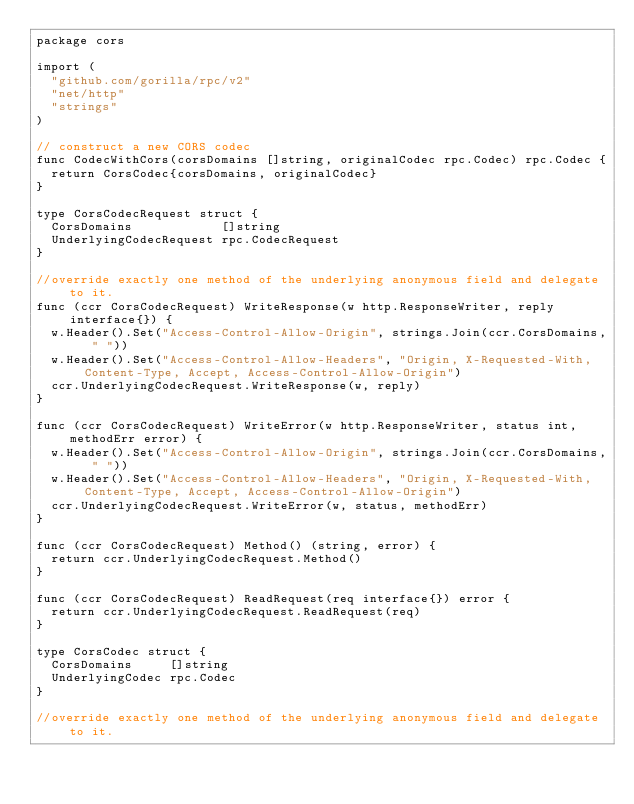Convert code to text. <code><loc_0><loc_0><loc_500><loc_500><_Go_>package cors

import (
	"github.com/gorilla/rpc/v2"
	"net/http"
	"strings"
)

// construct a new CORS codec
func CodecWithCors(corsDomains []string, originalCodec rpc.Codec) rpc.Codec {
	return CorsCodec{corsDomains, originalCodec}
}

type CorsCodecRequest struct {
	CorsDomains            []string
	UnderlyingCodecRequest rpc.CodecRequest
}

//override exactly one method of the underlying anonymous field and delegate to it.
func (ccr CorsCodecRequest) WriteResponse(w http.ResponseWriter, reply interface{}) {
	w.Header().Set("Access-Control-Allow-Origin", strings.Join(ccr.CorsDomains, " "))
	w.Header().Set("Access-Control-Allow-Headers", "Origin, X-Requested-With, Content-Type, Accept, Access-Control-Allow-Origin")
	ccr.UnderlyingCodecRequest.WriteResponse(w, reply)
}

func (ccr CorsCodecRequest) WriteError(w http.ResponseWriter, status int, methodErr error) {
	w.Header().Set("Access-Control-Allow-Origin", strings.Join(ccr.CorsDomains, " "))
	w.Header().Set("Access-Control-Allow-Headers", "Origin, X-Requested-With, Content-Type, Accept, Access-Control-Allow-Origin")
	ccr.UnderlyingCodecRequest.WriteError(w, status, methodErr)
}

func (ccr CorsCodecRequest) Method() (string, error) {
	return ccr.UnderlyingCodecRequest.Method()
}

func (ccr CorsCodecRequest) ReadRequest(req interface{}) error {
	return ccr.UnderlyingCodecRequest.ReadRequest(req)
}

type CorsCodec struct {
	CorsDomains     []string
	UnderlyingCodec rpc.Codec
}

//override exactly one method of the underlying anonymous field and delegate to it.</code> 